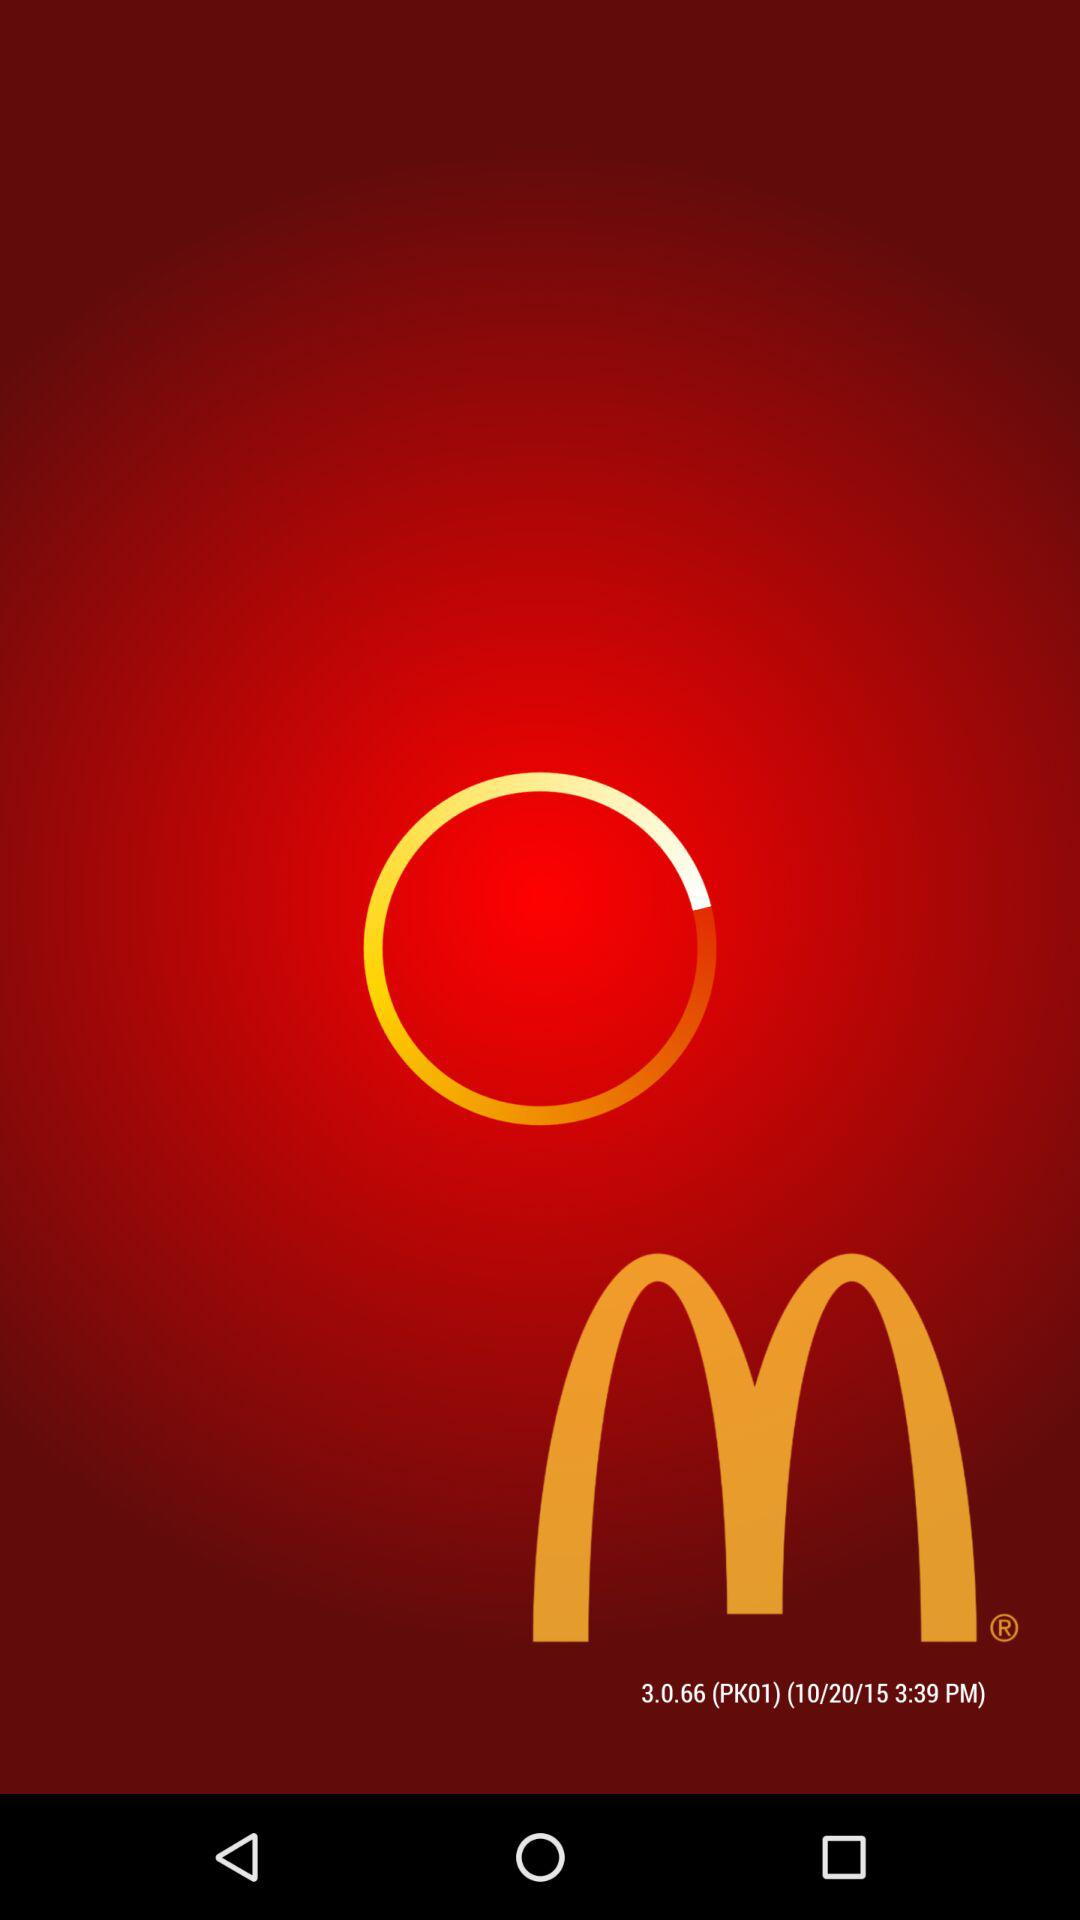What is the time? The time is 3:39 PM. 